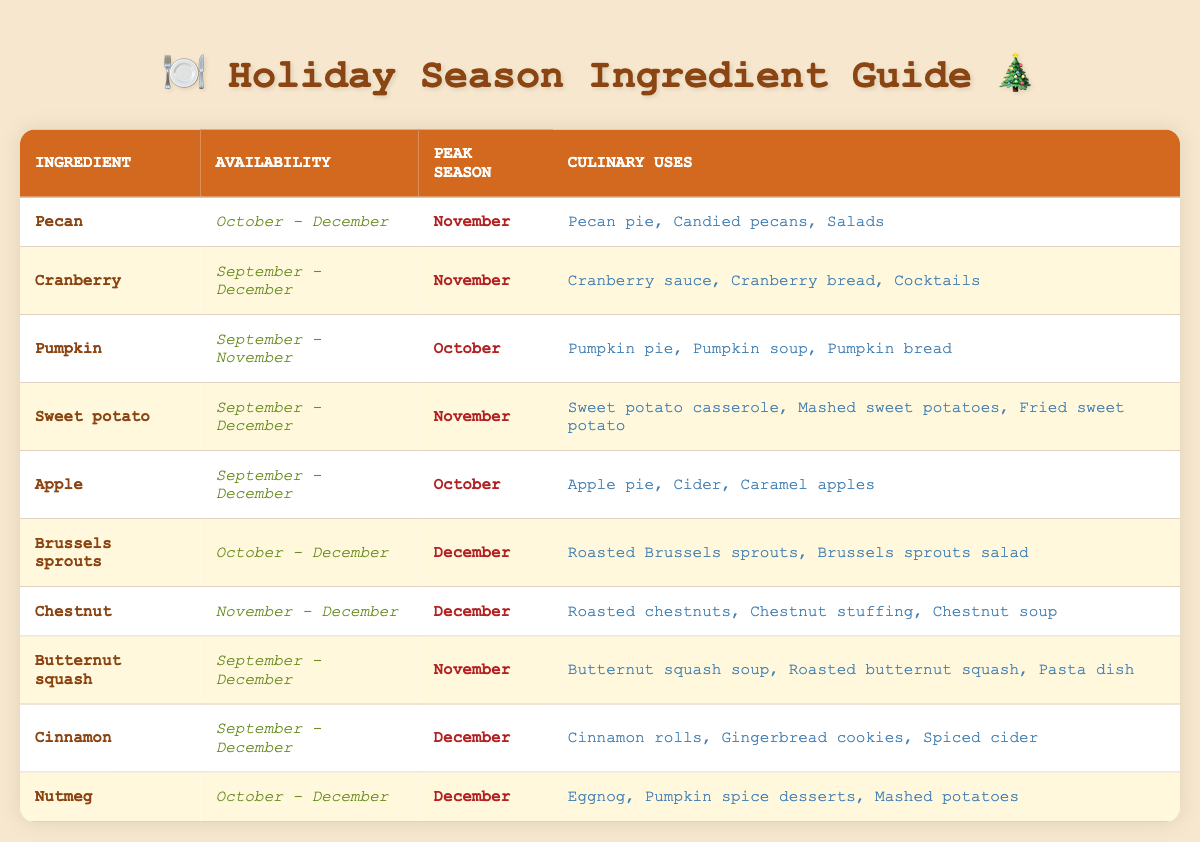What are the peak seasons for apples and cranberries? From the table, we can see that apples have a peak season in October and cranberries in November.
Answer: October for apples and November for cranberries Which ingredients are available in December? The ingredients available in December are cranberries, sweet potatoes, Brussels sprouts, chestnuts, butternut squash, cinnamon, and nutmeg.
Answer: Cranberries, sweet potatoes, Brussels sprouts, chestnuts, butternut squash, cinnamon, nutmeg True or False: Sweet potatoes are at their peak season in October. According to the table, sweet potatoes have their peak season in November, not October.
Answer: False How many ingredients have their peak season in November? The ingredients with peak seasons in November include pecans, cranberries, sweet potatoes, and butternut squash - that's four ingredients.
Answer: Four ingredients What is the total number of months that nutmeg is available? Nutmeg is available in October, November, and December, which totals three months.
Answer: Three months Do any of the ingredients peak in the same month? Pecan and sweet potato both peak in November, as do cranberries and butternut squash.
Answer: Yes, pecan and sweet potato, cranberries and butternut squash What is the difference in peak months between Brussels sprouts and pecans? Brussels sprouts peak in December while pecans peak in November, so the difference is one month as Brussels sprouts peak later.
Answer: One month Which ingredient is typically used in pumpkin spice desserts? The ingredient used in pumpkin spice desserts, according to the table, is nutmeg.
Answer: Nutmeg List the ingredients available in October along with their peak seasons. The ingredients available in October are pecan (peak in November), pumpkin (peak in October), apple (peak in October), sweet potato (peak in November), and Brussels sprouts (peak in December).
Answer: Pecan (November), Pumpkin (October), Apple (October), Sweet Potato (November), Brussels Sprouts (December) How many culinary uses does butternut squash have? According to the table, butternut squash has three culinary uses: butternut squash soup, roasted butternut squash, and a pasta dish.
Answer: Three culinary uses What ingredients peak in December and what are their uses? The ingredients that peak in December are Brussels sprouts (uses: roasted Brussels sprouts, salad), chestnuts (uses: roasted chestnuts, stuffing, soup), cinnamon (uses: rolls, cookies, cider), and nutmeg (uses: eggnog, desserts, potatoes).
Answer: Brussels sprouts, chestnuts, cinnamon, nutmeg 